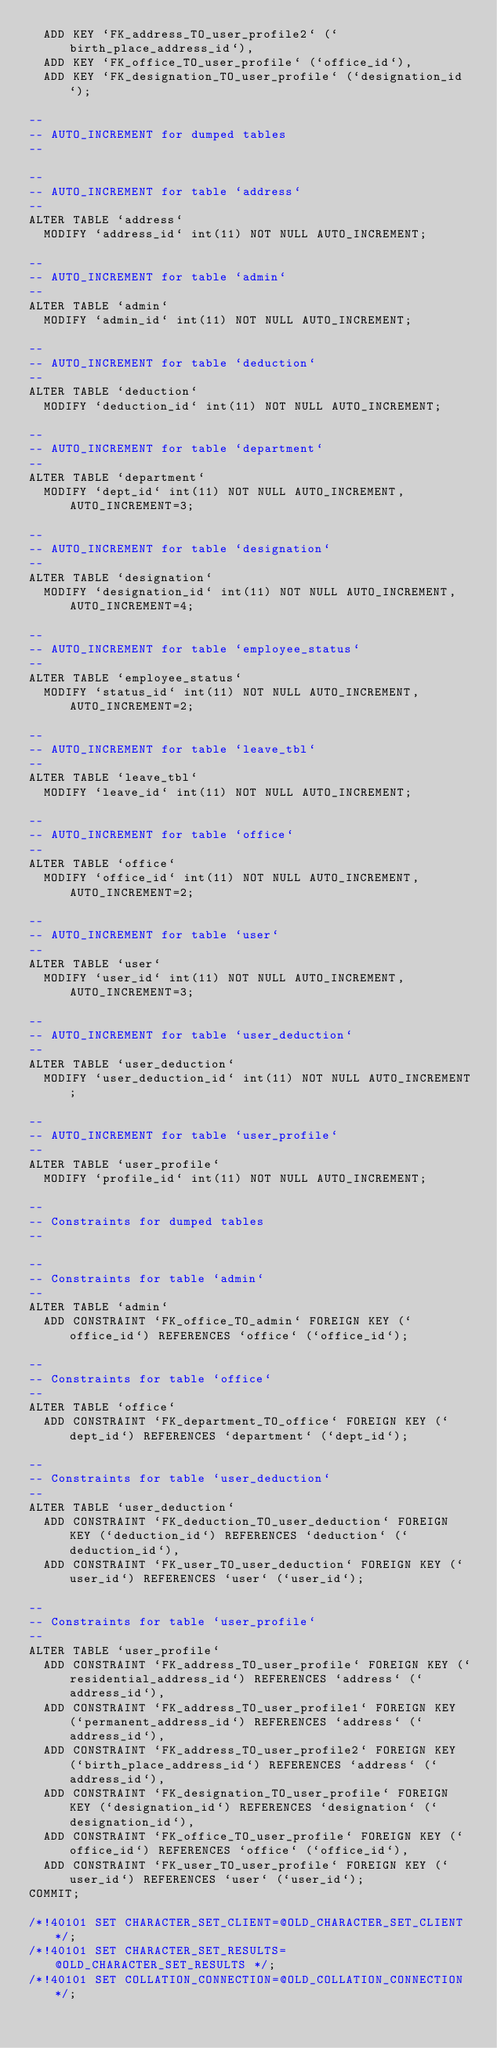Convert code to text. <code><loc_0><loc_0><loc_500><loc_500><_SQL_>  ADD KEY `FK_address_TO_user_profile2` (`birth_place_address_id`),
  ADD KEY `FK_office_TO_user_profile` (`office_id`),
  ADD KEY `FK_designation_TO_user_profile` (`designation_id`);

--
-- AUTO_INCREMENT for dumped tables
--

--
-- AUTO_INCREMENT for table `address`
--
ALTER TABLE `address`
  MODIFY `address_id` int(11) NOT NULL AUTO_INCREMENT;

--
-- AUTO_INCREMENT for table `admin`
--
ALTER TABLE `admin`
  MODIFY `admin_id` int(11) NOT NULL AUTO_INCREMENT;

--
-- AUTO_INCREMENT for table `deduction`
--
ALTER TABLE `deduction`
  MODIFY `deduction_id` int(11) NOT NULL AUTO_INCREMENT;

--
-- AUTO_INCREMENT for table `department`
--
ALTER TABLE `department`
  MODIFY `dept_id` int(11) NOT NULL AUTO_INCREMENT, AUTO_INCREMENT=3;

--
-- AUTO_INCREMENT for table `designation`
--
ALTER TABLE `designation`
  MODIFY `designation_id` int(11) NOT NULL AUTO_INCREMENT, AUTO_INCREMENT=4;

--
-- AUTO_INCREMENT for table `employee_status`
--
ALTER TABLE `employee_status`
  MODIFY `status_id` int(11) NOT NULL AUTO_INCREMENT, AUTO_INCREMENT=2;

--
-- AUTO_INCREMENT for table `leave_tbl`
--
ALTER TABLE `leave_tbl`
  MODIFY `leave_id` int(11) NOT NULL AUTO_INCREMENT;

--
-- AUTO_INCREMENT for table `office`
--
ALTER TABLE `office`
  MODIFY `office_id` int(11) NOT NULL AUTO_INCREMENT, AUTO_INCREMENT=2;

--
-- AUTO_INCREMENT for table `user`
--
ALTER TABLE `user`
  MODIFY `user_id` int(11) NOT NULL AUTO_INCREMENT, AUTO_INCREMENT=3;

--
-- AUTO_INCREMENT for table `user_deduction`
--
ALTER TABLE `user_deduction`
  MODIFY `user_deduction_id` int(11) NOT NULL AUTO_INCREMENT;

--
-- AUTO_INCREMENT for table `user_profile`
--
ALTER TABLE `user_profile`
  MODIFY `profile_id` int(11) NOT NULL AUTO_INCREMENT;

--
-- Constraints for dumped tables
--

--
-- Constraints for table `admin`
--
ALTER TABLE `admin`
  ADD CONSTRAINT `FK_office_TO_admin` FOREIGN KEY (`office_id`) REFERENCES `office` (`office_id`);

--
-- Constraints for table `office`
--
ALTER TABLE `office`
  ADD CONSTRAINT `FK_department_TO_office` FOREIGN KEY (`dept_id`) REFERENCES `department` (`dept_id`);

--
-- Constraints for table `user_deduction`
--
ALTER TABLE `user_deduction`
  ADD CONSTRAINT `FK_deduction_TO_user_deduction` FOREIGN KEY (`deduction_id`) REFERENCES `deduction` (`deduction_id`),
  ADD CONSTRAINT `FK_user_TO_user_deduction` FOREIGN KEY (`user_id`) REFERENCES `user` (`user_id`);

--
-- Constraints for table `user_profile`
--
ALTER TABLE `user_profile`
  ADD CONSTRAINT `FK_address_TO_user_profile` FOREIGN KEY (`residential_address_id`) REFERENCES `address` (`address_id`),
  ADD CONSTRAINT `FK_address_TO_user_profile1` FOREIGN KEY (`permanent_address_id`) REFERENCES `address` (`address_id`),
  ADD CONSTRAINT `FK_address_TO_user_profile2` FOREIGN KEY (`birth_place_address_id`) REFERENCES `address` (`address_id`),
  ADD CONSTRAINT `FK_designation_TO_user_profile` FOREIGN KEY (`designation_id`) REFERENCES `designation` (`designation_id`),
  ADD CONSTRAINT `FK_office_TO_user_profile` FOREIGN KEY (`office_id`) REFERENCES `office` (`office_id`),
  ADD CONSTRAINT `FK_user_TO_user_profile` FOREIGN KEY (`user_id`) REFERENCES `user` (`user_id`);
COMMIT;

/*!40101 SET CHARACTER_SET_CLIENT=@OLD_CHARACTER_SET_CLIENT */;
/*!40101 SET CHARACTER_SET_RESULTS=@OLD_CHARACTER_SET_RESULTS */;
/*!40101 SET COLLATION_CONNECTION=@OLD_COLLATION_CONNECTION */;
</code> 